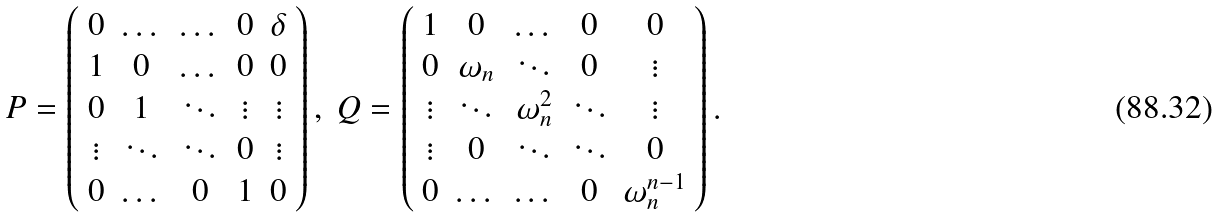Convert formula to latex. <formula><loc_0><loc_0><loc_500><loc_500>P = \left ( \begin{array} { c c c c c } 0 & \dots & \dots & 0 & \delta \\ 1 & 0 & \dots & 0 & 0 \\ 0 & 1 & \ddots & \vdots & \vdots \\ \vdots & \ddots & \ddots & 0 & \vdots \\ 0 & \dots & 0 & 1 & 0 \end{array} \right ) , \ Q = \left ( \begin{array} { c c c c c } 1 & 0 & \dots & 0 & 0 \\ 0 & \omega _ { n } & \ddots & 0 & \vdots \\ \vdots & \ddots & \omega _ { n } ^ { 2 } & \ddots & \vdots \\ \vdots & 0 & \ddots & \ddots & 0 \\ 0 & \dots & \dots & 0 & \omega _ { n } ^ { n - 1 } \end{array} \right ) .</formula> 